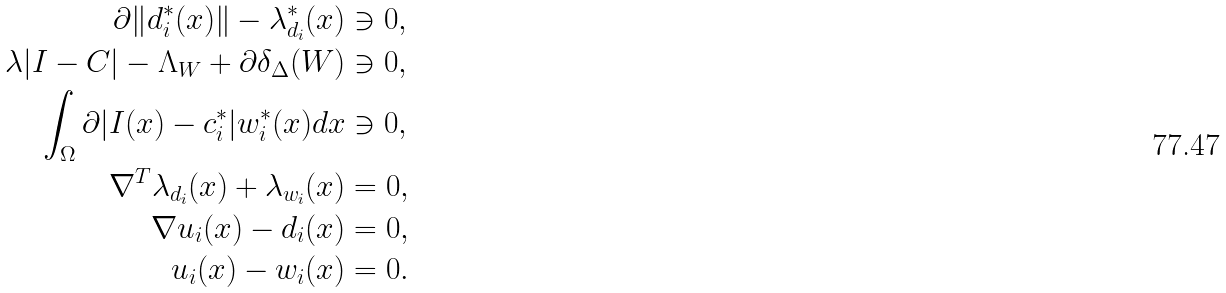Convert formula to latex. <formula><loc_0><loc_0><loc_500><loc_500>\partial \| d _ { i } ^ { * } ( x ) \| - { \lambda _ { d _ { i } } ^ { * } ( x ) } & \ni 0 , \\ \lambda | I - C | - \Lambda _ { W } + \partial \delta _ { \Delta } ( W ) & \ni 0 , \\ \int _ { \Omega } \partial | I ( x ) - c _ { i } ^ { * } | w ^ { * } _ { i } ( x ) d x & \ni 0 , \\ \nabla ^ { T } \lambda _ { d _ { i } } ( x ) + \lambda _ { w _ { i } } ( x ) & = 0 , \\ \nabla u _ { i } ( x ) - d _ { i } ( x ) & = 0 , \\ u _ { i } ( x ) - w _ { i } ( x ) & = 0 .</formula> 